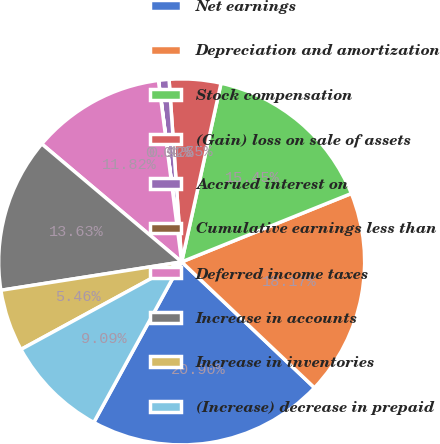<chart> <loc_0><loc_0><loc_500><loc_500><pie_chart><fcel>Net earnings<fcel>Depreciation and amortization<fcel>Stock compensation<fcel>(Gain) loss on sale of assets<fcel>Accrued interest on<fcel>Cumulative earnings less than<fcel>Deferred income taxes<fcel>Increase in accounts<fcel>Increase in inventories<fcel>(Increase) decrease in prepaid<nl><fcel>20.9%<fcel>18.17%<fcel>15.45%<fcel>4.55%<fcel>0.92%<fcel>0.01%<fcel>11.82%<fcel>13.63%<fcel>5.46%<fcel>9.09%<nl></chart> 